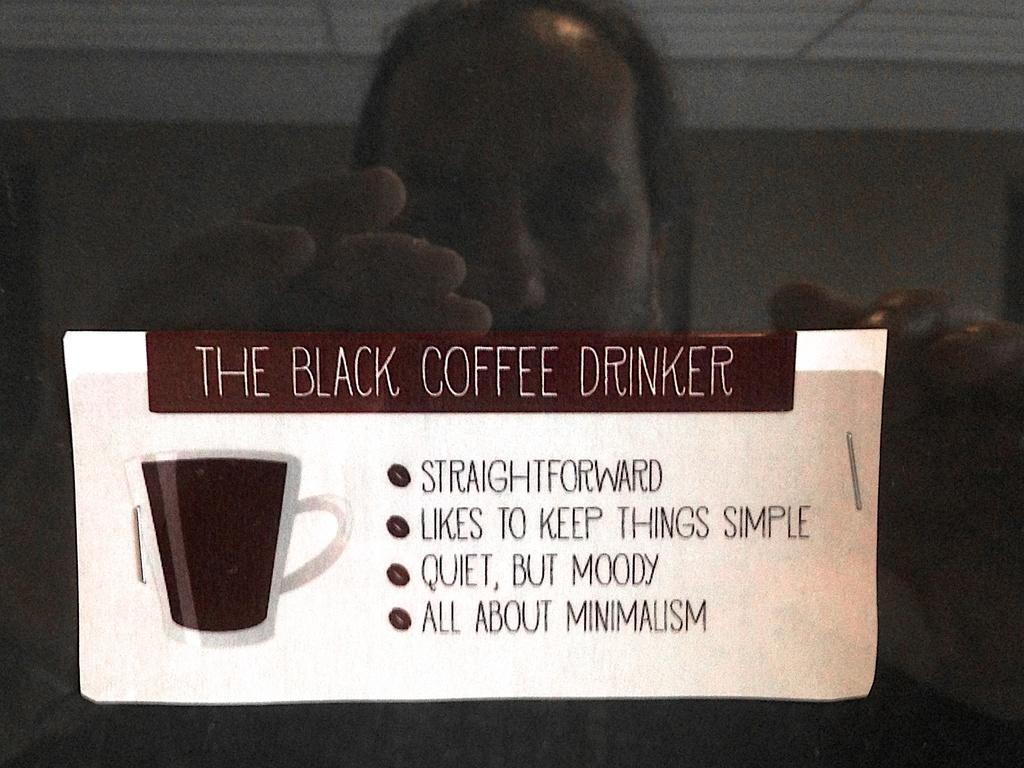What is the main subject in the image? There is a man standing in the image. What else can be seen in the image besides the man? There is a paper with text in the image. What type of flag is the man holding in the image? There is no flag present in the image; the man is not holding any object. 